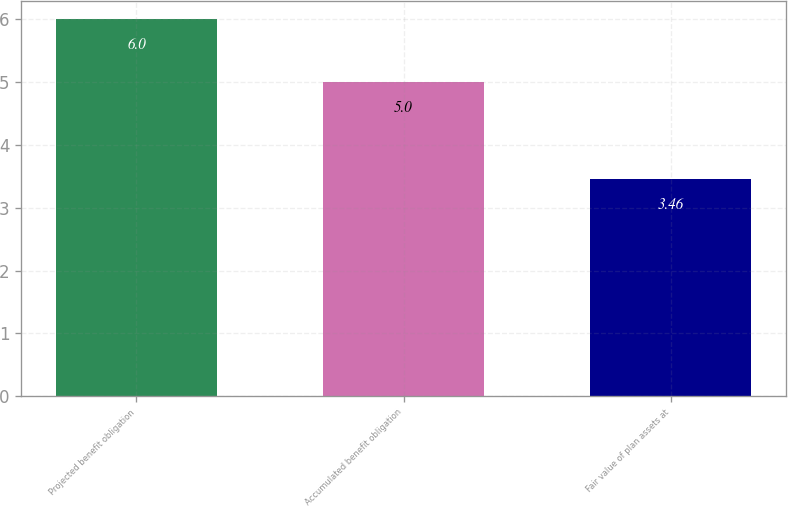Convert chart to OTSL. <chart><loc_0><loc_0><loc_500><loc_500><bar_chart><fcel>Projected benefit obligation<fcel>Accumulated benefit obligation<fcel>Fair value of plan assets at<nl><fcel>6<fcel>5<fcel>3.46<nl></chart> 